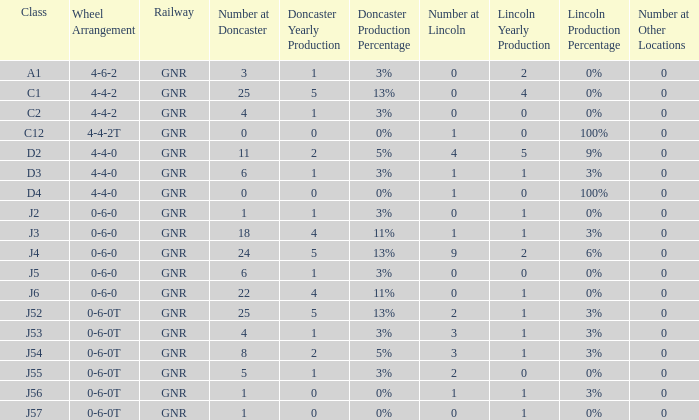Which Class has a Number at Lincoln smaller than 1 and a Wheel Arrangement of 0-6-0? J2, J5, J6. 